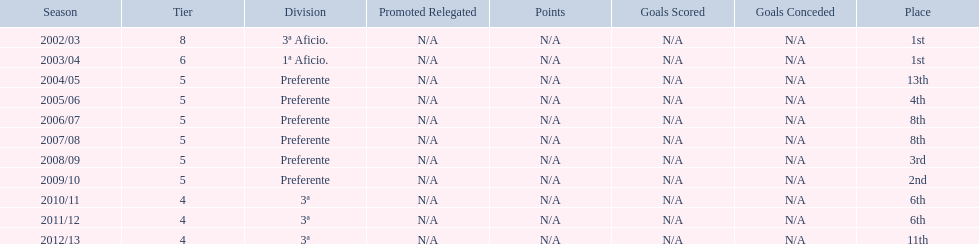How many times did  internacional de madrid cf come in 6th place? 6th, 6th. What is the first season that the team came in 6th place? 2010/11. Which season after the first did they place in 6th again? 2011/12. 